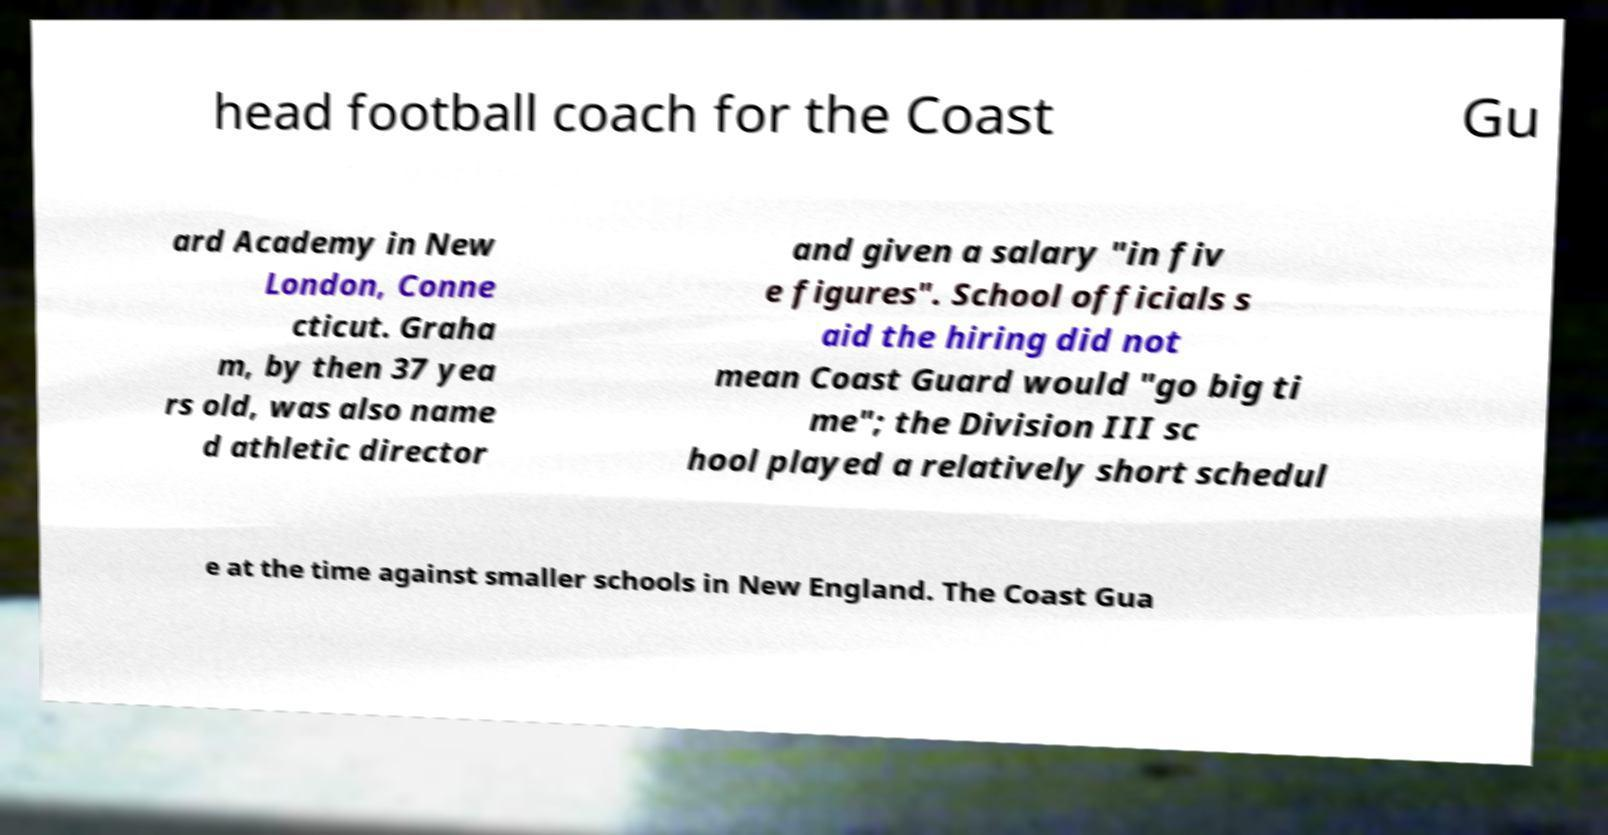What messages or text are displayed in this image? I need them in a readable, typed format. head football coach for the Coast Gu ard Academy in New London, Conne cticut. Graha m, by then 37 yea rs old, was also name d athletic director and given a salary "in fiv e figures". School officials s aid the hiring did not mean Coast Guard would "go big ti me"; the Division III sc hool played a relatively short schedul e at the time against smaller schools in New England. The Coast Gua 